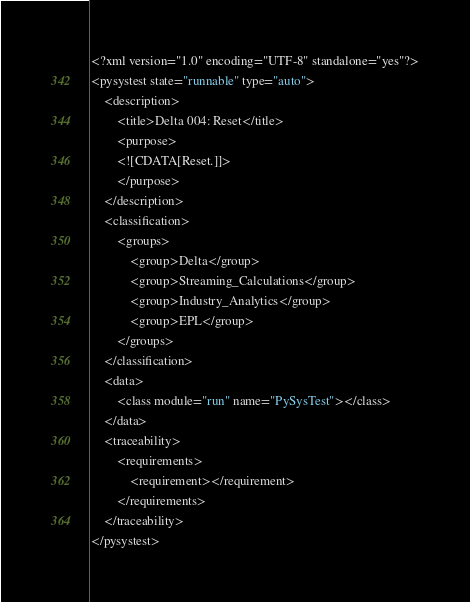<code> <loc_0><loc_0><loc_500><loc_500><_XML_><?xml version="1.0" encoding="UTF-8" standalone="yes"?>
<pysystest state="runnable" type="auto">
	<description>
		<title>Delta 004: Reset</title>
		<purpose>
		<![CDATA[Reset.]]>
		</purpose>
	</description>
	<classification>
		<groups>
			<group>Delta</group>
			<group>Streaming_Calculations</group>
			<group>Industry_Analytics</group>
			<group>EPL</group>
		</groups>
	</classification>
	<data>
		<class module="run" name="PySysTest"></class>
	</data>
	<traceability>
		<requirements>
			<requirement></requirement>
		</requirements>
	</traceability>
</pysystest></code> 